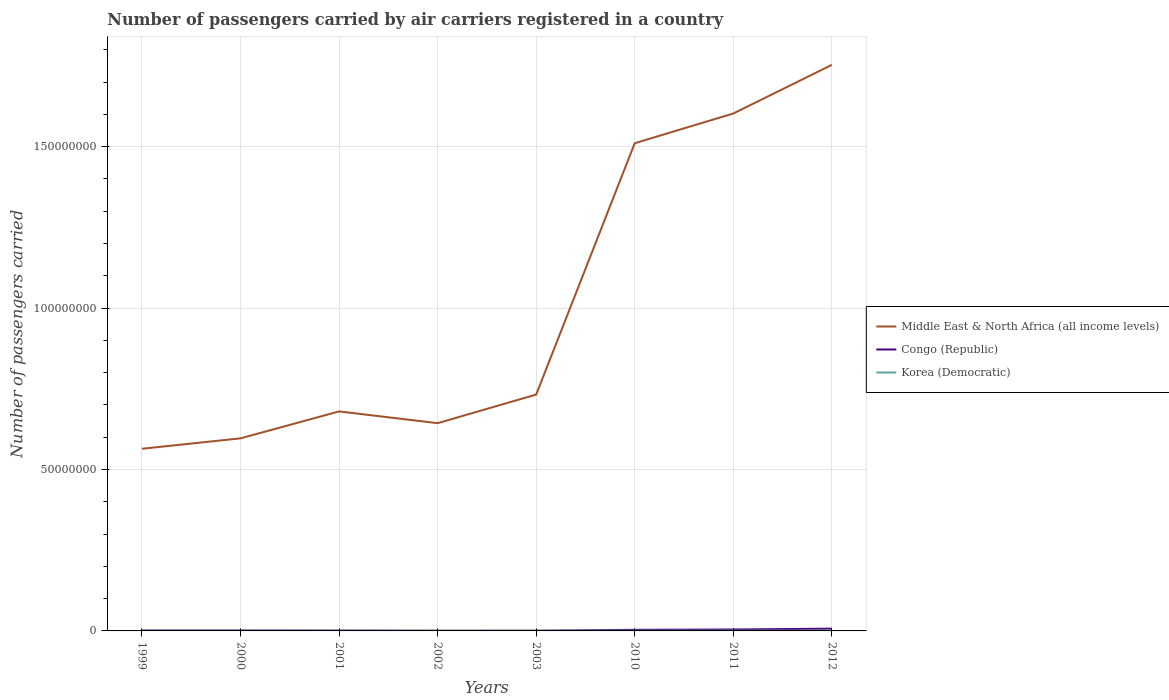How many different coloured lines are there?
Keep it short and to the point. 3. Is the number of lines equal to the number of legend labels?
Offer a terse response. Yes. Across all years, what is the maximum number of passengers carried by air carriers in Congo (Republic)?
Your answer should be very brief. 4.70e+04. What is the total number of passengers carried by air carriers in Middle East & North Africa (all income levels) in the graph?
Give a very brief answer. -1.36e+07. What is the difference between the highest and the second highest number of passengers carried by air carriers in Korea (Democratic)?
Make the answer very short. 2.71e+04. Is the number of passengers carried by air carriers in Middle East & North Africa (all income levels) strictly greater than the number of passengers carried by air carriers in Congo (Republic) over the years?
Give a very brief answer. No. How many lines are there?
Offer a very short reply. 3. What is the difference between two consecutive major ticks on the Y-axis?
Your answer should be very brief. 5.00e+07. Are the values on the major ticks of Y-axis written in scientific E-notation?
Ensure brevity in your answer.  No. Does the graph contain any zero values?
Offer a very short reply. No. Does the graph contain grids?
Ensure brevity in your answer.  Yes. Where does the legend appear in the graph?
Provide a short and direct response. Center right. What is the title of the graph?
Ensure brevity in your answer.  Number of passengers carried by air carriers registered in a country. Does "Bhutan" appear as one of the legend labels in the graph?
Ensure brevity in your answer.  No. What is the label or title of the X-axis?
Offer a very short reply. Years. What is the label or title of the Y-axis?
Offer a very short reply. Number of passengers carried. What is the Number of passengers carried of Middle East & North Africa (all income levels) in 1999?
Make the answer very short. 5.64e+07. What is the Number of passengers carried in Congo (Republic) in 1999?
Provide a succinct answer. 1.32e+05. What is the Number of passengers carried in Korea (Democratic) in 1999?
Provide a short and direct response. 7.67e+04. What is the Number of passengers carried in Middle East & North Africa (all income levels) in 2000?
Your response must be concise. 5.97e+07. What is the Number of passengers carried of Congo (Republic) in 2000?
Offer a very short reply. 1.28e+05. What is the Number of passengers carried in Korea (Democratic) in 2000?
Your response must be concise. 8.30e+04. What is the Number of passengers carried in Middle East & North Africa (all income levels) in 2001?
Offer a terse response. 6.80e+07. What is the Number of passengers carried in Congo (Republic) in 2001?
Your answer should be very brief. 9.52e+04. What is the Number of passengers carried in Korea (Democratic) in 2001?
Ensure brevity in your answer.  7.88e+04. What is the Number of passengers carried in Middle East & North Africa (all income levels) in 2002?
Offer a terse response. 6.44e+07. What is the Number of passengers carried of Congo (Republic) in 2002?
Make the answer very short. 4.70e+04. What is the Number of passengers carried of Korea (Democratic) in 2002?
Provide a short and direct response. 8.43e+04. What is the Number of passengers carried of Middle East & North Africa (all income levels) in 2003?
Offer a terse response. 7.32e+07. What is the Number of passengers carried of Congo (Republic) in 2003?
Provide a short and direct response. 5.23e+04. What is the Number of passengers carried in Korea (Democratic) in 2003?
Offer a terse response. 7.50e+04. What is the Number of passengers carried of Middle East & North Africa (all income levels) in 2010?
Your response must be concise. 1.51e+08. What is the Number of passengers carried of Congo (Republic) in 2010?
Your response must be concise. 3.42e+05. What is the Number of passengers carried in Korea (Democratic) in 2010?
Offer a terse response. 7.31e+04. What is the Number of passengers carried of Middle East & North Africa (all income levels) in 2011?
Offer a terse response. 1.60e+08. What is the Number of passengers carried of Congo (Republic) in 2011?
Offer a terse response. 4.38e+05. What is the Number of passengers carried in Korea (Democratic) in 2011?
Your response must be concise. 7.86e+04. What is the Number of passengers carried of Middle East & North Africa (all income levels) in 2012?
Provide a short and direct response. 1.75e+08. What is the Number of passengers carried of Congo (Republic) in 2012?
Your answer should be compact. 7.04e+05. What is the Number of passengers carried in Korea (Democratic) in 2012?
Provide a succinct answer. 1.00e+05. Across all years, what is the maximum Number of passengers carried of Middle East & North Africa (all income levels)?
Your answer should be very brief. 1.75e+08. Across all years, what is the maximum Number of passengers carried of Congo (Republic)?
Offer a very short reply. 7.04e+05. Across all years, what is the maximum Number of passengers carried of Korea (Democratic)?
Provide a succinct answer. 1.00e+05. Across all years, what is the minimum Number of passengers carried of Middle East & North Africa (all income levels)?
Your answer should be very brief. 5.64e+07. Across all years, what is the minimum Number of passengers carried in Congo (Republic)?
Ensure brevity in your answer.  4.70e+04. Across all years, what is the minimum Number of passengers carried in Korea (Democratic)?
Your response must be concise. 7.31e+04. What is the total Number of passengers carried of Middle East & North Africa (all income levels) in the graph?
Provide a short and direct response. 8.08e+08. What is the total Number of passengers carried in Congo (Republic) in the graph?
Your answer should be very brief. 1.94e+06. What is the total Number of passengers carried of Korea (Democratic) in the graph?
Your response must be concise. 6.50e+05. What is the difference between the Number of passengers carried in Middle East & North Africa (all income levels) in 1999 and that in 2000?
Your response must be concise. -3.23e+06. What is the difference between the Number of passengers carried in Congo (Republic) in 1999 and that in 2000?
Give a very brief answer. 4659. What is the difference between the Number of passengers carried in Korea (Democratic) in 1999 and that in 2000?
Your answer should be compact. -6253. What is the difference between the Number of passengers carried of Middle East & North Africa (all income levels) in 1999 and that in 2001?
Your answer should be very brief. -1.16e+07. What is the difference between the Number of passengers carried of Congo (Republic) in 1999 and that in 2001?
Provide a succinct answer. 3.70e+04. What is the difference between the Number of passengers carried in Korea (Democratic) in 1999 and that in 2001?
Your response must be concise. -2105. What is the difference between the Number of passengers carried of Middle East & North Africa (all income levels) in 1999 and that in 2002?
Provide a short and direct response. -7.93e+06. What is the difference between the Number of passengers carried in Congo (Republic) in 1999 and that in 2002?
Your response must be concise. 8.52e+04. What is the difference between the Number of passengers carried in Korea (Democratic) in 1999 and that in 2002?
Your response must be concise. -7621. What is the difference between the Number of passengers carried of Middle East & North Africa (all income levels) in 1999 and that in 2003?
Your answer should be very brief. -1.68e+07. What is the difference between the Number of passengers carried of Congo (Republic) in 1999 and that in 2003?
Your answer should be very brief. 7.99e+04. What is the difference between the Number of passengers carried of Korea (Democratic) in 1999 and that in 2003?
Make the answer very short. 1654. What is the difference between the Number of passengers carried of Middle East & North Africa (all income levels) in 1999 and that in 2010?
Provide a succinct answer. -9.46e+07. What is the difference between the Number of passengers carried in Congo (Republic) in 1999 and that in 2010?
Provide a succinct answer. -2.09e+05. What is the difference between the Number of passengers carried in Korea (Democratic) in 1999 and that in 2010?
Offer a terse response. 3648. What is the difference between the Number of passengers carried of Middle East & North Africa (all income levels) in 1999 and that in 2011?
Your answer should be compact. -1.04e+08. What is the difference between the Number of passengers carried of Congo (Republic) in 1999 and that in 2011?
Ensure brevity in your answer.  -3.06e+05. What is the difference between the Number of passengers carried in Korea (Democratic) in 1999 and that in 2011?
Offer a terse response. -1858.86. What is the difference between the Number of passengers carried of Middle East & North Africa (all income levels) in 1999 and that in 2012?
Your response must be concise. -1.19e+08. What is the difference between the Number of passengers carried in Congo (Republic) in 1999 and that in 2012?
Provide a short and direct response. -5.72e+05. What is the difference between the Number of passengers carried of Korea (Democratic) in 1999 and that in 2012?
Provide a short and direct response. -2.34e+04. What is the difference between the Number of passengers carried in Middle East & North Africa (all income levels) in 2000 and that in 2001?
Offer a terse response. -8.34e+06. What is the difference between the Number of passengers carried of Congo (Republic) in 2000 and that in 2001?
Give a very brief answer. 3.24e+04. What is the difference between the Number of passengers carried of Korea (Democratic) in 2000 and that in 2001?
Make the answer very short. 4148. What is the difference between the Number of passengers carried in Middle East & North Africa (all income levels) in 2000 and that in 2002?
Ensure brevity in your answer.  -4.70e+06. What is the difference between the Number of passengers carried of Congo (Republic) in 2000 and that in 2002?
Your answer should be very brief. 8.06e+04. What is the difference between the Number of passengers carried in Korea (Democratic) in 2000 and that in 2002?
Your response must be concise. -1368. What is the difference between the Number of passengers carried in Middle East & North Africa (all income levels) in 2000 and that in 2003?
Keep it short and to the point. -1.36e+07. What is the difference between the Number of passengers carried in Congo (Republic) in 2000 and that in 2003?
Keep it short and to the point. 7.53e+04. What is the difference between the Number of passengers carried in Korea (Democratic) in 2000 and that in 2003?
Offer a terse response. 7907. What is the difference between the Number of passengers carried of Middle East & North Africa (all income levels) in 2000 and that in 2010?
Offer a very short reply. -9.14e+07. What is the difference between the Number of passengers carried in Congo (Republic) in 2000 and that in 2010?
Ensure brevity in your answer.  -2.14e+05. What is the difference between the Number of passengers carried of Korea (Democratic) in 2000 and that in 2010?
Your answer should be very brief. 9901. What is the difference between the Number of passengers carried of Middle East & North Africa (all income levels) in 2000 and that in 2011?
Ensure brevity in your answer.  -1.01e+08. What is the difference between the Number of passengers carried of Congo (Republic) in 2000 and that in 2011?
Provide a succinct answer. -3.11e+05. What is the difference between the Number of passengers carried of Korea (Democratic) in 2000 and that in 2011?
Provide a succinct answer. 4394.14. What is the difference between the Number of passengers carried of Middle East & North Africa (all income levels) in 2000 and that in 2012?
Make the answer very short. -1.16e+08. What is the difference between the Number of passengers carried of Congo (Republic) in 2000 and that in 2012?
Your answer should be very brief. -5.76e+05. What is the difference between the Number of passengers carried in Korea (Democratic) in 2000 and that in 2012?
Provide a short and direct response. -1.72e+04. What is the difference between the Number of passengers carried in Middle East & North Africa (all income levels) in 2001 and that in 2002?
Provide a short and direct response. 3.64e+06. What is the difference between the Number of passengers carried of Congo (Republic) in 2001 and that in 2002?
Offer a very short reply. 4.82e+04. What is the difference between the Number of passengers carried in Korea (Democratic) in 2001 and that in 2002?
Offer a very short reply. -5516. What is the difference between the Number of passengers carried in Middle East & North Africa (all income levels) in 2001 and that in 2003?
Your answer should be very brief. -5.23e+06. What is the difference between the Number of passengers carried in Congo (Republic) in 2001 and that in 2003?
Provide a short and direct response. 4.29e+04. What is the difference between the Number of passengers carried in Korea (Democratic) in 2001 and that in 2003?
Your answer should be compact. 3759. What is the difference between the Number of passengers carried in Middle East & North Africa (all income levels) in 2001 and that in 2010?
Offer a very short reply. -8.31e+07. What is the difference between the Number of passengers carried of Congo (Republic) in 2001 and that in 2010?
Ensure brevity in your answer.  -2.46e+05. What is the difference between the Number of passengers carried in Korea (Democratic) in 2001 and that in 2010?
Your answer should be compact. 5753. What is the difference between the Number of passengers carried of Middle East & North Africa (all income levels) in 2001 and that in 2011?
Give a very brief answer. -9.23e+07. What is the difference between the Number of passengers carried of Congo (Republic) in 2001 and that in 2011?
Your answer should be compact. -3.43e+05. What is the difference between the Number of passengers carried in Korea (Democratic) in 2001 and that in 2011?
Offer a very short reply. 246.14. What is the difference between the Number of passengers carried of Middle East & North Africa (all income levels) in 2001 and that in 2012?
Your answer should be very brief. -1.07e+08. What is the difference between the Number of passengers carried in Congo (Republic) in 2001 and that in 2012?
Ensure brevity in your answer.  -6.09e+05. What is the difference between the Number of passengers carried in Korea (Democratic) in 2001 and that in 2012?
Your response must be concise. -2.13e+04. What is the difference between the Number of passengers carried of Middle East & North Africa (all income levels) in 2002 and that in 2003?
Keep it short and to the point. -8.86e+06. What is the difference between the Number of passengers carried in Congo (Republic) in 2002 and that in 2003?
Offer a very short reply. -5301. What is the difference between the Number of passengers carried of Korea (Democratic) in 2002 and that in 2003?
Provide a succinct answer. 9275. What is the difference between the Number of passengers carried of Middle East & North Africa (all income levels) in 2002 and that in 2010?
Your response must be concise. -8.67e+07. What is the difference between the Number of passengers carried of Congo (Republic) in 2002 and that in 2010?
Your answer should be compact. -2.95e+05. What is the difference between the Number of passengers carried in Korea (Democratic) in 2002 and that in 2010?
Offer a very short reply. 1.13e+04. What is the difference between the Number of passengers carried in Middle East & North Africa (all income levels) in 2002 and that in 2011?
Your answer should be compact. -9.59e+07. What is the difference between the Number of passengers carried in Congo (Republic) in 2002 and that in 2011?
Provide a succinct answer. -3.91e+05. What is the difference between the Number of passengers carried in Korea (Democratic) in 2002 and that in 2011?
Keep it short and to the point. 5762.14. What is the difference between the Number of passengers carried of Middle East & North Africa (all income levels) in 2002 and that in 2012?
Make the answer very short. -1.11e+08. What is the difference between the Number of passengers carried of Congo (Republic) in 2002 and that in 2012?
Your answer should be very brief. -6.57e+05. What is the difference between the Number of passengers carried in Korea (Democratic) in 2002 and that in 2012?
Give a very brief answer. -1.58e+04. What is the difference between the Number of passengers carried of Middle East & North Africa (all income levels) in 2003 and that in 2010?
Make the answer very short. -7.79e+07. What is the difference between the Number of passengers carried in Congo (Republic) in 2003 and that in 2010?
Your answer should be compact. -2.89e+05. What is the difference between the Number of passengers carried of Korea (Democratic) in 2003 and that in 2010?
Your response must be concise. 1994. What is the difference between the Number of passengers carried of Middle East & North Africa (all income levels) in 2003 and that in 2011?
Keep it short and to the point. -8.71e+07. What is the difference between the Number of passengers carried of Congo (Republic) in 2003 and that in 2011?
Your response must be concise. -3.86e+05. What is the difference between the Number of passengers carried of Korea (Democratic) in 2003 and that in 2011?
Offer a very short reply. -3512.86. What is the difference between the Number of passengers carried of Middle East & North Africa (all income levels) in 2003 and that in 2012?
Offer a terse response. -1.02e+08. What is the difference between the Number of passengers carried in Congo (Republic) in 2003 and that in 2012?
Offer a very short reply. -6.52e+05. What is the difference between the Number of passengers carried of Korea (Democratic) in 2003 and that in 2012?
Offer a very short reply. -2.51e+04. What is the difference between the Number of passengers carried of Middle East & North Africa (all income levels) in 2010 and that in 2011?
Give a very brief answer. -9.20e+06. What is the difference between the Number of passengers carried in Congo (Republic) in 2010 and that in 2011?
Provide a succinct answer. -9.65e+04. What is the difference between the Number of passengers carried of Korea (Democratic) in 2010 and that in 2011?
Your response must be concise. -5506.86. What is the difference between the Number of passengers carried of Middle East & North Africa (all income levels) in 2010 and that in 2012?
Your response must be concise. -2.43e+07. What is the difference between the Number of passengers carried in Congo (Republic) in 2010 and that in 2012?
Offer a very short reply. -3.62e+05. What is the difference between the Number of passengers carried of Korea (Democratic) in 2010 and that in 2012?
Provide a succinct answer. -2.71e+04. What is the difference between the Number of passengers carried in Middle East & North Africa (all income levels) in 2011 and that in 2012?
Keep it short and to the point. -1.51e+07. What is the difference between the Number of passengers carried of Congo (Republic) in 2011 and that in 2012?
Make the answer very short. -2.66e+05. What is the difference between the Number of passengers carried of Korea (Democratic) in 2011 and that in 2012?
Provide a short and direct response. -2.16e+04. What is the difference between the Number of passengers carried in Middle East & North Africa (all income levels) in 1999 and the Number of passengers carried in Congo (Republic) in 2000?
Ensure brevity in your answer.  5.63e+07. What is the difference between the Number of passengers carried of Middle East & North Africa (all income levels) in 1999 and the Number of passengers carried of Korea (Democratic) in 2000?
Offer a very short reply. 5.63e+07. What is the difference between the Number of passengers carried of Congo (Republic) in 1999 and the Number of passengers carried of Korea (Democratic) in 2000?
Offer a very short reply. 4.92e+04. What is the difference between the Number of passengers carried of Middle East & North Africa (all income levels) in 1999 and the Number of passengers carried of Congo (Republic) in 2001?
Offer a very short reply. 5.63e+07. What is the difference between the Number of passengers carried of Middle East & North Africa (all income levels) in 1999 and the Number of passengers carried of Korea (Democratic) in 2001?
Provide a short and direct response. 5.63e+07. What is the difference between the Number of passengers carried in Congo (Republic) in 1999 and the Number of passengers carried in Korea (Democratic) in 2001?
Make the answer very short. 5.34e+04. What is the difference between the Number of passengers carried of Middle East & North Africa (all income levels) in 1999 and the Number of passengers carried of Congo (Republic) in 2002?
Your answer should be compact. 5.64e+07. What is the difference between the Number of passengers carried in Middle East & North Africa (all income levels) in 1999 and the Number of passengers carried in Korea (Democratic) in 2002?
Provide a short and direct response. 5.63e+07. What is the difference between the Number of passengers carried of Congo (Republic) in 1999 and the Number of passengers carried of Korea (Democratic) in 2002?
Provide a succinct answer. 4.79e+04. What is the difference between the Number of passengers carried of Middle East & North Africa (all income levels) in 1999 and the Number of passengers carried of Congo (Republic) in 2003?
Your answer should be very brief. 5.64e+07. What is the difference between the Number of passengers carried in Middle East & North Africa (all income levels) in 1999 and the Number of passengers carried in Korea (Democratic) in 2003?
Offer a very short reply. 5.63e+07. What is the difference between the Number of passengers carried in Congo (Republic) in 1999 and the Number of passengers carried in Korea (Democratic) in 2003?
Your answer should be very brief. 5.72e+04. What is the difference between the Number of passengers carried of Middle East & North Africa (all income levels) in 1999 and the Number of passengers carried of Congo (Republic) in 2010?
Keep it short and to the point. 5.61e+07. What is the difference between the Number of passengers carried of Middle East & North Africa (all income levels) in 1999 and the Number of passengers carried of Korea (Democratic) in 2010?
Offer a very short reply. 5.64e+07. What is the difference between the Number of passengers carried in Congo (Republic) in 1999 and the Number of passengers carried in Korea (Democratic) in 2010?
Offer a very short reply. 5.91e+04. What is the difference between the Number of passengers carried in Middle East & North Africa (all income levels) in 1999 and the Number of passengers carried in Congo (Republic) in 2011?
Your response must be concise. 5.60e+07. What is the difference between the Number of passengers carried in Middle East & North Africa (all income levels) in 1999 and the Number of passengers carried in Korea (Democratic) in 2011?
Give a very brief answer. 5.63e+07. What is the difference between the Number of passengers carried in Congo (Republic) in 1999 and the Number of passengers carried in Korea (Democratic) in 2011?
Make the answer very short. 5.36e+04. What is the difference between the Number of passengers carried of Middle East & North Africa (all income levels) in 1999 and the Number of passengers carried of Congo (Republic) in 2012?
Offer a terse response. 5.57e+07. What is the difference between the Number of passengers carried in Middle East & North Africa (all income levels) in 1999 and the Number of passengers carried in Korea (Democratic) in 2012?
Ensure brevity in your answer.  5.63e+07. What is the difference between the Number of passengers carried in Congo (Republic) in 1999 and the Number of passengers carried in Korea (Democratic) in 2012?
Your response must be concise. 3.21e+04. What is the difference between the Number of passengers carried in Middle East & North Africa (all income levels) in 2000 and the Number of passengers carried in Congo (Republic) in 2001?
Provide a succinct answer. 5.96e+07. What is the difference between the Number of passengers carried in Middle East & North Africa (all income levels) in 2000 and the Number of passengers carried in Korea (Democratic) in 2001?
Ensure brevity in your answer.  5.96e+07. What is the difference between the Number of passengers carried in Congo (Republic) in 2000 and the Number of passengers carried in Korea (Democratic) in 2001?
Keep it short and to the point. 4.87e+04. What is the difference between the Number of passengers carried in Middle East & North Africa (all income levels) in 2000 and the Number of passengers carried in Congo (Republic) in 2002?
Your response must be concise. 5.96e+07. What is the difference between the Number of passengers carried of Middle East & North Africa (all income levels) in 2000 and the Number of passengers carried of Korea (Democratic) in 2002?
Make the answer very short. 5.96e+07. What is the difference between the Number of passengers carried of Congo (Republic) in 2000 and the Number of passengers carried of Korea (Democratic) in 2002?
Your response must be concise. 4.32e+04. What is the difference between the Number of passengers carried in Middle East & North Africa (all income levels) in 2000 and the Number of passengers carried in Congo (Republic) in 2003?
Ensure brevity in your answer.  5.96e+07. What is the difference between the Number of passengers carried of Middle East & North Africa (all income levels) in 2000 and the Number of passengers carried of Korea (Democratic) in 2003?
Offer a terse response. 5.96e+07. What is the difference between the Number of passengers carried in Congo (Republic) in 2000 and the Number of passengers carried in Korea (Democratic) in 2003?
Ensure brevity in your answer.  5.25e+04. What is the difference between the Number of passengers carried in Middle East & North Africa (all income levels) in 2000 and the Number of passengers carried in Congo (Republic) in 2010?
Your answer should be compact. 5.93e+07. What is the difference between the Number of passengers carried of Middle East & North Africa (all income levels) in 2000 and the Number of passengers carried of Korea (Democratic) in 2010?
Offer a very short reply. 5.96e+07. What is the difference between the Number of passengers carried of Congo (Republic) in 2000 and the Number of passengers carried of Korea (Democratic) in 2010?
Provide a succinct answer. 5.45e+04. What is the difference between the Number of passengers carried of Middle East & North Africa (all income levels) in 2000 and the Number of passengers carried of Congo (Republic) in 2011?
Keep it short and to the point. 5.92e+07. What is the difference between the Number of passengers carried of Middle East & North Africa (all income levels) in 2000 and the Number of passengers carried of Korea (Democratic) in 2011?
Offer a terse response. 5.96e+07. What is the difference between the Number of passengers carried in Congo (Republic) in 2000 and the Number of passengers carried in Korea (Democratic) in 2011?
Your answer should be very brief. 4.90e+04. What is the difference between the Number of passengers carried in Middle East & North Africa (all income levels) in 2000 and the Number of passengers carried in Congo (Republic) in 2012?
Ensure brevity in your answer.  5.90e+07. What is the difference between the Number of passengers carried in Middle East & North Africa (all income levels) in 2000 and the Number of passengers carried in Korea (Democratic) in 2012?
Your answer should be compact. 5.96e+07. What is the difference between the Number of passengers carried of Congo (Republic) in 2000 and the Number of passengers carried of Korea (Democratic) in 2012?
Ensure brevity in your answer.  2.74e+04. What is the difference between the Number of passengers carried in Middle East & North Africa (all income levels) in 2001 and the Number of passengers carried in Congo (Republic) in 2002?
Keep it short and to the point. 6.79e+07. What is the difference between the Number of passengers carried of Middle East & North Africa (all income levels) in 2001 and the Number of passengers carried of Korea (Democratic) in 2002?
Give a very brief answer. 6.79e+07. What is the difference between the Number of passengers carried in Congo (Republic) in 2001 and the Number of passengers carried in Korea (Democratic) in 2002?
Keep it short and to the point. 1.09e+04. What is the difference between the Number of passengers carried in Middle East & North Africa (all income levels) in 2001 and the Number of passengers carried in Congo (Republic) in 2003?
Make the answer very short. 6.79e+07. What is the difference between the Number of passengers carried in Middle East & North Africa (all income levels) in 2001 and the Number of passengers carried in Korea (Democratic) in 2003?
Your answer should be very brief. 6.79e+07. What is the difference between the Number of passengers carried of Congo (Republic) in 2001 and the Number of passengers carried of Korea (Democratic) in 2003?
Your answer should be compact. 2.01e+04. What is the difference between the Number of passengers carried of Middle East & North Africa (all income levels) in 2001 and the Number of passengers carried of Congo (Republic) in 2010?
Provide a succinct answer. 6.76e+07. What is the difference between the Number of passengers carried in Middle East & North Africa (all income levels) in 2001 and the Number of passengers carried in Korea (Democratic) in 2010?
Make the answer very short. 6.79e+07. What is the difference between the Number of passengers carried in Congo (Republic) in 2001 and the Number of passengers carried in Korea (Democratic) in 2010?
Your response must be concise. 2.21e+04. What is the difference between the Number of passengers carried of Middle East & North Africa (all income levels) in 2001 and the Number of passengers carried of Congo (Republic) in 2011?
Offer a terse response. 6.76e+07. What is the difference between the Number of passengers carried of Middle East & North Africa (all income levels) in 2001 and the Number of passengers carried of Korea (Democratic) in 2011?
Your answer should be very brief. 6.79e+07. What is the difference between the Number of passengers carried of Congo (Republic) in 2001 and the Number of passengers carried of Korea (Democratic) in 2011?
Your answer should be very brief. 1.66e+04. What is the difference between the Number of passengers carried of Middle East & North Africa (all income levels) in 2001 and the Number of passengers carried of Congo (Republic) in 2012?
Provide a short and direct response. 6.73e+07. What is the difference between the Number of passengers carried of Middle East & North Africa (all income levels) in 2001 and the Number of passengers carried of Korea (Democratic) in 2012?
Your response must be concise. 6.79e+07. What is the difference between the Number of passengers carried of Congo (Republic) in 2001 and the Number of passengers carried of Korea (Democratic) in 2012?
Give a very brief answer. -4925.35. What is the difference between the Number of passengers carried of Middle East & North Africa (all income levels) in 2002 and the Number of passengers carried of Congo (Republic) in 2003?
Your answer should be very brief. 6.43e+07. What is the difference between the Number of passengers carried of Middle East & North Africa (all income levels) in 2002 and the Number of passengers carried of Korea (Democratic) in 2003?
Provide a succinct answer. 6.43e+07. What is the difference between the Number of passengers carried of Congo (Republic) in 2002 and the Number of passengers carried of Korea (Democratic) in 2003?
Provide a short and direct response. -2.81e+04. What is the difference between the Number of passengers carried in Middle East & North Africa (all income levels) in 2002 and the Number of passengers carried in Congo (Republic) in 2010?
Your answer should be very brief. 6.40e+07. What is the difference between the Number of passengers carried of Middle East & North Africa (all income levels) in 2002 and the Number of passengers carried of Korea (Democratic) in 2010?
Your answer should be compact. 6.43e+07. What is the difference between the Number of passengers carried of Congo (Republic) in 2002 and the Number of passengers carried of Korea (Democratic) in 2010?
Offer a terse response. -2.61e+04. What is the difference between the Number of passengers carried in Middle East & North Africa (all income levels) in 2002 and the Number of passengers carried in Congo (Republic) in 2011?
Provide a short and direct response. 6.39e+07. What is the difference between the Number of passengers carried of Middle East & North Africa (all income levels) in 2002 and the Number of passengers carried of Korea (Democratic) in 2011?
Provide a short and direct response. 6.43e+07. What is the difference between the Number of passengers carried of Congo (Republic) in 2002 and the Number of passengers carried of Korea (Democratic) in 2011?
Ensure brevity in your answer.  -3.16e+04. What is the difference between the Number of passengers carried of Middle East & North Africa (all income levels) in 2002 and the Number of passengers carried of Congo (Republic) in 2012?
Provide a short and direct response. 6.37e+07. What is the difference between the Number of passengers carried of Middle East & North Africa (all income levels) in 2002 and the Number of passengers carried of Korea (Democratic) in 2012?
Make the answer very short. 6.43e+07. What is the difference between the Number of passengers carried of Congo (Republic) in 2002 and the Number of passengers carried of Korea (Democratic) in 2012?
Offer a terse response. -5.31e+04. What is the difference between the Number of passengers carried of Middle East & North Africa (all income levels) in 2003 and the Number of passengers carried of Congo (Republic) in 2010?
Keep it short and to the point. 7.29e+07. What is the difference between the Number of passengers carried in Middle East & North Africa (all income levels) in 2003 and the Number of passengers carried in Korea (Democratic) in 2010?
Make the answer very short. 7.31e+07. What is the difference between the Number of passengers carried in Congo (Republic) in 2003 and the Number of passengers carried in Korea (Democratic) in 2010?
Your response must be concise. -2.08e+04. What is the difference between the Number of passengers carried of Middle East & North Africa (all income levels) in 2003 and the Number of passengers carried of Congo (Republic) in 2011?
Provide a short and direct response. 7.28e+07. What is the difference between the Number of passengers carried in Middle East & North Africa (all income levels) in 2003 and the Number of passengers carried in Korea (Democratic) in 2011?
Provide a succinct answer. 7.31e+07. What is the difference between the Number of passengers carried in Congo (Republic) in 2003 and the Number of passengers carried in Korea (Democratic) in 2011?
Your answer should be compact. -2.63e+04. What is the difference between the Number of passengers carried in Middle East & North Africa (all income levels) in 2003 and the Number of passengers carried in Congo (Republic) in 2012?
Keep it short and to the point. 7.25e+07. What is the difference between the Number of passengers carried in Middle East & North Africa (all income levels) in 2003 and the Number of passengers carried in Korea (Democratic) in 2012?
Keep it short and to the point. 7.31e+07. What is the difference between the Number of passengers carried in Congo (Republic) in 2003 and the Number of passengers carried in Korea (Democratic) in 2012?
Your answer should be compact. -4.78e+04. What is the difference between the Number of passengers carried in Middle East & North Africa (all income levels) in 2010 and the Number of passengers carried in Congo (Republic) in 2011?
Your answer should be compact. 1.51e+08. What is the difference between the Number of passengers carried of Middle East & North Africa (all income levels) in 2010 and the Number of passengers carried of Korea (Democratic) in 2011?
Offer a very short reply. 1.51e+08. What is the difference between the Number of passengers carried of Congo (Republic) in 2010 and the Number of passengers carried of Korea (Democratic) in 2011?
Offer a very short reply. 2.63e+05. What is the difference between the Number of passengers carried of Middle East & North Africa (all income levels) in 2010 and the Number of passengers carried of Congo (Republic) in 2012?
Offer a terse response. 1.50e+08. What is the difference between the Number of passengers carried in Middle East & North Africa (all income levels) in 2010 and the Number of passengers carried in Korea (Democratic) in 2012?
Give a very brief answer. 1.51e+08. What is the difference between the Number of passengers carried of Congo (Republic) in 2010 and the Number of passengers carried of Korea (Democratic) in 2012?
Offer a very short reply. 2.42e+05. What is the difference between the Number of passengers carried in Middle East & North Africa (all income levels) in 2011 and the Number of passengers carried in Congo (Republic) in 2012?
Provide a short and direct response. 1.60e+08. What is the difference between the Number of passengers carried of Middle East & North Africa (all income levels) in 2011 and the Number of passengers carried of Korea (Democratic) in 2012?
Make the answer very short. 1.60e+08. What is the difference between the Number of passengers carried in Congo (Republic) in 2011 and the Number of passengers carried in Korea (Democratic) in 2012?
Ensure brevity in your answer.  3.38e+05. What is the average Number of passengers carried in Middle East & North Africa (all income levels) per year?
Provide a short and direct response. 1.01e+08. What is the average Number of passengers carried of Congo (Republic) per year?
Give a very brief answer. 2.42e+05. What is the average Number of passengers carried of Korea (Democratic) per year?
Provide a succinct answer. 8.12e+04. In the year 1999, what is the difference between the Number of passengers carried in Middle East & North Africa (all income levels) and Number of passengers carried in Congo (Republic)?
Make the answer very short. 5.63e+07. In the year 1999, what is the difference between the Number of passengers carried of Middle East & North Africa (all income levels) and Number of passengers carried of Korea (Democratic)?
Provide a succinct answer. 5.63e+07. In the year 1999, what is the difference between the Number of passengers carried in Congo (Republic) and Number of passengers carried in Korea (Democratic)?
Ensure brevity in your answer.  5.55e+04. In the year 2000, what is the difference between the Number of passengers carried of Middle East & North Africa (all income levels) and Number of passengers carried of Congo (Republic)?
Your response must be concise. 5.95e+07. In the year 2000, what is the difference between the Number of passengers carried of Middle East & North Africa (all income levels) and Number of passengers carried of Korea (Democratic)?
Give a very brief answer. 5.96e+07. In the year 2000, what is the difference between the Number of passengers carried in Congo (Republic) and Number of passengers carried in Korea (Democratic)?
Keep it short and to the point. 4.46e+04. In the year 2001, what is the difference between the Number of passengers carried of Middle East & North Africa (all income levels) and Number of passengers carried of Congo (Republic)?
Keep it short and to the point. 6.79e+07. In the year 2001, what is the difference between the Number of passengers carried in Middle East & North Africa (all income levels) and Number of passengers carried in Korea (Democratic)?
Keep it short and to the point. 6.79e+07. In the year 2001, what is the difference between the Number of passengers carried of Congo (Republic) and Number of passengers carried of Korea (Democratic)?
Your response must be concise. 1.64e+04. In the year 2002, what is the difference between the Number of passengers carried in Middle East & North Africa (all income levels) and Number of passengers carried in Congo (Republic)?
Provide a short and direct response. 6.43e+07. In the year 2002, what is the difference between the Number of passengers carried in Middle East & North Africa (all income levels) and Number of passengers carried in Korea (Democratic)?
Offer a very short reply. 6.43e+07. In the year 2002, what is the difference between the Number of passengers carried in Congo (Republic) and Number of passengers carried in Korea (Democratic)?
Your response must be concise. -3.74e+04. In the year 2003, what is the difference between the Number of passengers carried in Middle East & North Africa (all income levels) and Number of passengers carried in Congo (Republic)?
Your response must be concise. 7.32e+07. In the year 2003, what is the difference between the Number of passengers carried of Middle East & North Africa (all income levels) and Number of passengers carried of Korea (Democratic)?
Offer a very short reply. 7.31e+07. In the year 2003, what is the difference between the Number of passengers carried of Congo (Republic) and Number of passengers carried of Korea (Democratic)?
Ensure brevity in your answer.  -2.28e+04. In the year 2010, what is the difference between the Number of passengers carried in Middle East & North Africa (all income levels) and Number of passengers carried in Congo (Republic)?
Your response must be concise. 1.51e+08. In the year 2010, what is the difference between the Number of passengers carried in Middle East & North Africa (all income levels) and Number of passengers carried in Korea (Democratic)?
Your answer should be very brief. 1.51e+08. In the year 2010, what is the difference between the Number of passengers carried in Congo (Republic) and Number of passengers carried in Korea (Democratic)?
Your answer should be compact. 2.69e+05. In the year 2011, what is the difference between the Number of passengers carried in Middle East & North Africa (all income levels) and Number of passengers carried in Congo (Republic)?
Ensure brevity in your answer.  1.60e+08. In the year 2011, what is the difference between the Number of passengers carried in Middle East & North Africa (all income levels) and Number of passengers carried in Korea (Democratic)?
Offer a terse response. 1.60e+08. In the year 2011, what is the difference between the Number of passengers carried in Congo (Republic) and Number of passengers carried in Korea (Democratic)?
Make the answer very short. 3.60e+05. In the year 2012, what is the difference between the Number of passengers carried in Middle East & North Africa (all income levels) and Number of passengers carried in Congo (Republic)?
Give a very brief answer. 1.75e+08. In the year 2012, what is the difference between the Number of passengers carried of Middle East & North Africa (all income levels) and Number of passengers carried of Korea (Democratic)?
Keep it short and to the point. 1.75e+08. In the year 2012, what is the difference between the Number of passengers carried of Congo (Republic) and Number of passengers carried of Korea (Democratic)?
Keep it short and to the point. 6.04e+05. What is the ratio of the Number of passengers carried of Middle East & North Africa (all income levels) in 1999 to that in 2000?
Your answer should be compact. 0.95. What is the ratio of the Number of passengers carried in Congo (Republic) in 1999 to that in 2000?
Ensure brevity in your answer.  1.04. What is the ratio of the Number of passengers carried in Korea (Democratic) in 1999 to that in 2000?
Give a very brief answer. 0.92. What is the ratio of the Number of passengers carried of Middle East & North Africa (all income levels) in 1999 to that in 2001?
Your response must be concise. 0.83. What is the ratio of the Number of passengers carried of Congo (Republic) in 1999 to that in 2001?
Your answer should be compact. 1.39. What is the ratio of the Number of passengers carried in Korea (Democratic) in 1999 to that in 2001?
Give a very brief answer. 0.97. What is the ratio of the Number of passengers carried of Middle East & North Africa (all income levels) in 1999 to that in 2002?
Give a very brief answer. 0.88. What is the ratio of the Number of passengers carried of Congo (Republic) in 1999 to that in 2002?
Your answer should be very brief. 2.81. What is the ratio of the Number of passengers carried of Korea (Democratic) in 1999 to that in 2002?
Offer a terse response. 0.91. What is the ratio of the Number of passengers carried of Middle East & North Africa (all income levels) in 1999 to that in 2003?
Offer a very short reply. 0.77. What is the ratio of the Number of passengers carried of Congo (Republic) in 1999 to that in 2003?
Offer a terse response. 2.53. What is the ratio of the Number of passengers carried of Middle East & North Africa (all income levels) in 1999 to that in 2010?
Your answer should be very brief. 0.37. What is the ratio of the Number of passengers carried of Congo (Republic) in 1999 to that in 2010?
Make the answer very short. 0.39. What is the ratio of the Number of passengers carried of Korea (Democratic) in 1999 to that in 2010?
Give a very brief answer. 1.05. What is the ratio of the Number of passengers carried of Middle East & North Africa (all income levels) in 1999 to that in 2011?
Your response must be concise. 0.35. What is the ratio of the Number of passengers carried of Congo (Republic) in 1999 to that in 2011?
Your answer should be very brief. 0.3. What is the ratio of the Number of passengers carried in Korea (Democratic) in 1999 to that in 2011?
Your answer should be compact. 0.98. What is the ratio of the Number of passengers carried in Middle East & North Africa (all income levels) in 1999 to that in 2012?
Offer a terse response. 0.32. What is the ratio of the Number of passengers carried in Congo (Republic) in 1999 to that in 2012?
Make the answer very short. 0.19. What is the ratio of the Number of passengers carried in Korea (Democratic) in 1999 to that in 2012?
Your response must be concise. 0.77. What is the ratio of the Number of passengers carried of Middle East & North Africa (all income levels) in 2000 to that in 2001?
Keep it short and to the point. 0.88. What is the ratio of the Number of passengers carried of Congo (Republic) in 2000 to that in 2001?
Provide a succinct answer. 1.34. What is the ratio of the Number of passengers carried of Korea (Democratic) in 2000 to that in 2001?
Your answer should be compact. 1.05. What is the ratio of the Number of passengers carried in Middle East & North Africa (all income levels) in 2000 to that in 2002?
Provide a succinct answer. 0.93. What is the ratio of the Number of passengers carried in Congo (Republic) in 2000 to that in 2002?
Your answer should be compact. 2.72. What is the ratio of the Number of passengers carried in Korea (Democratic) in 2000 to that in 2002?
Offer a terse response. 0.98. What is the ratio of the Number of passengers carried of Middle East & North Africa (all income levels) in 2000 to that in 2003?
Offer a very short reply. 0.81. What is the ratio of the Number of passengers carried in Congo (Republic) in 2000 to that in 2003?
Keep it short and to the point. 2.44. What is the ratio of the Number of passengers carried in Korea (Democratic) in 2000 to that in 2003?
Provide a succinct answer. 1.11. What is the ratio of the Number of passengers carried in Middle East & North Africa (all income levels) in 2000 to that in 2010?
Provide a succinct answer. 0.39. What is the ratio of the Number of passengers carried of Congo (Republic) in 2000 to that in 2010?
Provide a succinct answer. 0.37. What is the ratio of the Number of passengers carried in Korea (Democratic) in 2000 to that in 2010?
Offer a very short reply. 1.14. What is the ratio of the Number of passengers carried of Middle East & North Africa (all income levels) in 2000 to that in 2011?
Your answer should be compact. 0.37. What is the ratio of the Number of passengers carried of Congo (Republic) in 2000 to that in 2011?
Provide a short and direct response. 0.29. What is the ratio of the Number of passengers carried in Korea (Democratic) in 2000 to that in 2011?
Your answer should be compact. 1.06. What is the ratio of the Number of passengers carried of Middle East & North Africa (all income levels) in 2000 to that in 2012?
Offer a terse response. 0.34. What is the ratio of the Number of passengers carried of Congo (Republic) in 2000 to that in 2012?
Your response must be concise. 0.18. What is the ratio of the Number of passengers carried in Korea (Democratic) in 2000 to that in 2012?
Give a very brief answer. 0.83. What is the ratio of the Number of passengers carried in Middle East & North Africa (all income levels) in 2001 to that in 2002?
Provide a succinct answer. 1.06. What is the ratio of the Number of passengers carried in Congo (Republic) in 2001 to that in 2002?
Keep it short and to the point. 2.03. What is the ratio of the Number of passengers carried of Korea (Democratic) in 2001 to that in 2002?
Your answer should be compact. 0.93. What is the ratio of the Number of passengers carried of Congo (Republic) in 2001 to that in 2003?
Provide a short and direct response. 1.82. What is the ratio of the Number of passengers carried in Korea (Democratic) in 2001 to that in 2003?
Offer a very short reply. 1.05. What is the ratio of the Number of passengers carried in Middle East & North Africa (all income levels) in 2001 to that in 2010?
Provide a succinct answer. 0.45. What is the ratio of the Number of passengers carried of Congo (Republic) in 2001 to that in 2010?
Provide a succinct answer. 0.28. What is the ratio of the Number of passengers carried of Korea (Democratic) in 2001 to that in 2010?
Offer a very short reply. 1.08. What is the ratio of the Number of passengers carried in Middle East & North Africa (all income levels) in 2001 to that in 2011?
Ensure brevity in your answer.  0.42. What is the ratio of the Number of passengers carried of Congo (Republic) in 2001 to that in 2011?
Provide a succinct answer. 0.22. What is the ratio of the Number of passengers carried in Korea (Democratic) in 2001 to that in 2011?
Offer a terse response. 1. What is the ratio of the Number of passengers carried in Middle East & North Africa (all income levels) in 2001 to that in 2012?
Your response must be concise. 0.39. What is the ratio of the Number of passengers carried of Congo (Republic) in 2001 to that in 2012?
Your response must be concise. 0.14. What is the ratio of the Number of passengers carried of Korea (Democratic) in 2001 to that in 2012?
Make the answer very short. 0.79. What is the ratio of the Number of passengers carried in Middle East & North Africa (all income levels) in 2002 to that in 2003?
Keep it short and to the point. 0.88. What is the ratio of the Number of passengers carried of Congo (Republic) in 2002 to that in 2003?
Provide a succinct answer. 0.9. What is the ratio of the Number of passengers carried of Korea (Democratic) in 2002 to that in 2003?
Provide a succinct answer. 1.12. What is the ratio of the Number of passengers carried in Middle East & North Africa (all income levels) in 2002 to that in 2010?
Provide a short and direct response. 0.43. What is the ratio of the Number of passengers carried in Congo (Republic) in 2002 to that in 2010?
Offer a terse response. 0.14. What is the ratio of the Number of passengers carried of Korea (Democratic) in 2002 to that in 2010?
Make the answer very short. 1.15. What is the ratio of the Number of passengers carried in Middle East & North Africa (all income levels) in 2002 to that in 2011?
Your answer should be very brief. 0.4. What is the ratio of the Number of passengers carried of Congo (Republic) in 2002 to that in 2011?
Ensure brevity in your answer.  0.11. What is the ratio of the Number of passengers carried in Korea (Democratic) in 2002 to that in 2011?
Provide a succinct answer. 1.07. What is the ratio of the Number of passengers carried in Middle East & North Africa (all income levels) in 2002 to that in 2012?
Your answer should be very brief. 0.37. What is the ratio of the Number of passengers carried in Congo (Republic) in 2002 to that in 2012?
Give a very brief answer. 0.07. What is the ratio of the Number of passengers carried in Korea (Democratic) in 2002 to that in 2012?
Keep it short and to the point. 0.84. What is the ratio of the Number of passengers carried of Middle East & North Africa (all income levels) in 2003 to that in 2010?
Provide a succinct answer. 0.48. What is the ratio of the Number of passengers carried in Congo (Republic) in 2003 to that in 2010?
Your answer should be very brief. 0.15. What is the ratio of the Number of passengers carried in Korea (Democratic) in 2003 to that in 2010?
Provide a succinct answer. 1.03. What is the ratio of the Number of passengers carried of Middle East & North Africa (all income levels) in 2003 to that in 2011?
Give a very brief answer. 0.46. What is the ratio of the Number of passengers carried in Congo (Republic) in 2003 to that in 2011?
Your response must be concise. 0.12. What is the ratio of the Number of passengers carried of Korea (Democratic) in 2003 to that in 2011?
Your response must be concise. 0.96. What is the ratio of the Number of passengers carried in Middle East & North Africa (all income levels) in 2003 to that in 2012?
Offer a terse response. 0.42. What is the ratio of the Number of passengers carried in Congo (Republic) in 2003 to that in 2012?
Your answer should be very brief. 0.07. What is the ratio of the Number of passengers carried of Korea (Democratic) in 2003 to that in 2012?
Ensure brevity in your answer.  0.75. What is the ratio of the Number of passengers carried in Middle East & North Africa (all income levels) in 2010 to that in 2011?
Ensure brevity in your answer.  0.94. What is the ratio of the Number of passengers carried of Congo (Republic) in 2010 to that in 2011?
Provide a succinct answer. 0.78. What is the ratio of the Number of passengers carried of Korea (Democratic) in 2010 to that in 2011?
Your answer should be very brief. 0.93. What is the ratio of the Number of passengers carried in Middle East & North Africa (all income levels) in 2010 to that in 2012?
Your answer should be compact. 0.86. What is the ratio of the Number of passengers carried of Congo (Republic) in 2010 to that in 2012?
Your response must be concise. 0.49. What is the ratio of the Number of passengers carried in Korea (Democratic) in 2010 to that in 2012?
Offer a terse response. 0.73. What is the ratio of the Number of passengers carried of Middle East & North Africa (all income levels) in 2011 to that in 2012?
Offer a terse response. 0.91. What is the ratio of the Number of passengers carried in Congo (Republic) in 2011 to that in 2012?
Make the answer very short. 0.62. What is the ratio of the Number of passengers carried in Korea (Democratic) in 2011 to that in 2012?
Ensure brevity in your answer.  0.78. What is the difference between the highest and the second highest Number of passengers carried in Middle East & North Africa (all income levels)?
Ensure brevity in your answer.  1.51e+07. What is the difference between the highest and the second highest Number of passengers carried in Congo (Republic)?
Your answer should be very brief. 2.66e+05. What is the difference between the highest and the second highest Number of passengers carried of Korea (Democratic)?
Keep it short and to the point. 1.58e+04. What is the difference between the highest and the lowest Number of passengers carried in Middle East & North Africa (all income levels)?
Offer a terse response. 1.19e+08. What is the difference between the highest and the lowest Number of passengers carried in Congo (Republic)?
Ensure brevity in your answer.  6.57e+05. What is the difference between the highest and the lowest Number of passengers carried of Korea (Democratic)?
Your answer should be very brief. 2.71e+04. 